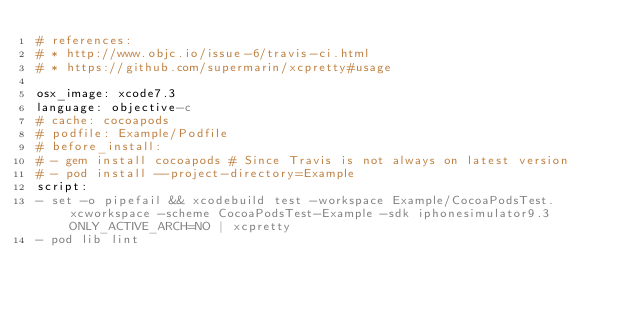<code> <loc_0><loc_0><loc_500><loc_500><_YAML_># references:
# * http://www.objc.io/issue-6/travis-ci.html
# * https://github.com/supermarin/xcpretty#usage

osx_image: xcode7.3
language: objective-c
# cache: cocoapods
# podfile: Example/Podfile
# before_install:
# - gem install cocoapods # Since Travis is not always on latest version
# - pod install --project-directory=Example
script:
- set -o pipefail && xcodebuild test -workspace Example/CocoaPodsTest.xcworkspace -scheme CocoaPodsTest-Example -sdk iphonesimulator9.3 ONLY_ACTIVE_ARCH=NO | xcpretty
- pod lib lint
</code> 